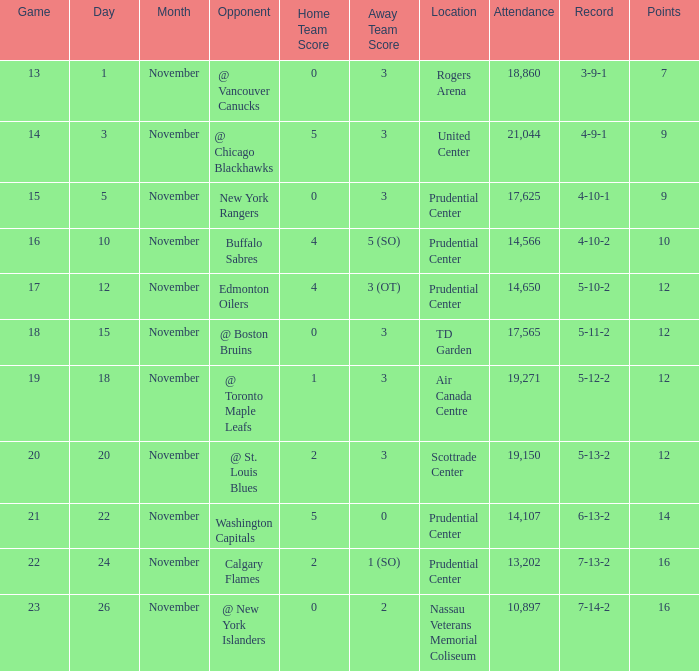What is the total number of locations that had a score of 1-3? 1.0. 